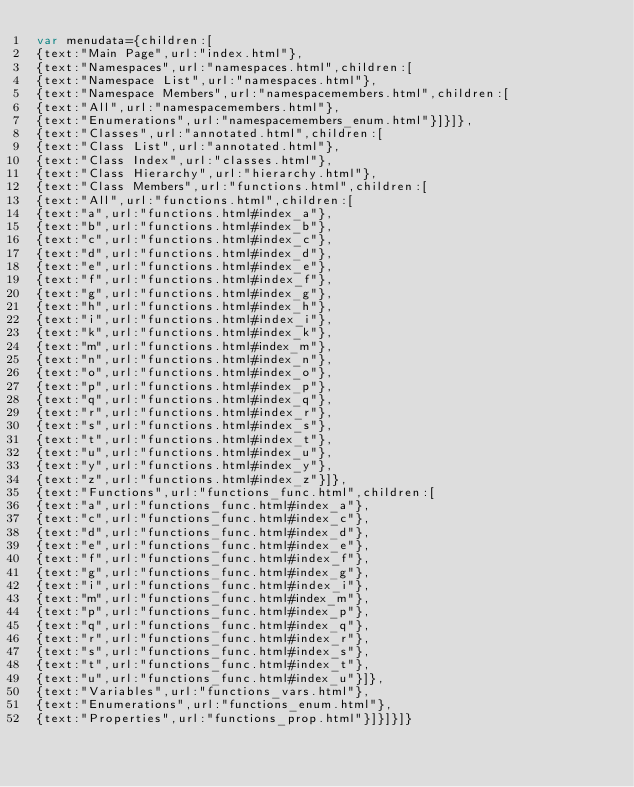<code> <loc_0><loc_0><loc_500><loc_500><_JavaScript_>var menudata={children:[
{text:"Main Page",url:"index.html"},
{text:"Namespaces",url:"namespaces.html",children:[
{text:"Namespace List",url:"namespaces.html"},
{text:"Namespace Members",url:"namespacemembers.html",children:[
{text:"All",url:"namespacemembers.html"},
{text:"Enumerations",url:"namespacemembers_enum.html"}]}]},
{text:"Classes",url:"annotated.html",children:[
{text:"Class List",url:"annotated.html"},
{text:"Class Index",url:"classes.html"},
{text:"Class Hierarchy",url:"hierarchy.html"},
{text:"Class Members",url:"functions.html",children:[
{text:"All",url:"functions.html",children:[
{text:"a",url:"functions.html#index_a"},
{text:"b",url:"functions.html#index_b"},
{text:"c",url:"functions.html#index_c"},
{text:"d",url:"functions.html#index_d"},
{text:"e",url:"functions.html#index_e"},
{text:"f",url:"functions.html#index_f"},
{text:"g",url:"functions.html#index_g"},
{text:"h",url:"functions.html#index_h"},
{text:"i",url:"functions.html#index_i"},
{text:"k",url:"functions.html#index_k"},
{text:"m",url:"functions.html#index_m"},
{text:"n",url:"functions.html#index_n"},
{text:"o",url:"functions.html#index_o"},
{text:"p",url:"functions.html#index_p"},
{text:"q",url:"functions.html#index_q"},
{text:"r",url:"functions.html#index_r"},
{text:"s",url:"functions.html#index_s"},
{text:"t",url:"functions.html#index_t"},
{text:"u",url:"functions.html#index_u"},
{text:"y",url:"functions.html#index_y"},
{text:"z",url:"functions.html#index_z"}]},
{text:"Functions",url:"functions_func.html",children:[
{text:"a",url:"functions_func.html#index_a"},
{text:"c",url:"functions_func.html#index_c"},
{text:"d",url:"functions_func.html#index_d"},
{text:"e",url:"functions_func.html#index_e"},
{text:"f",url:"functions_func.html#index_f"},
{text:"g",url:"functions_func.html#index_g"},
{text:"i",url:"functions_func.html#index_i"},
{text:"m",url:"functions_func.html#index_m"},
{text:"p",url:"functions_func.html#index_p"},
{text:"q",url:"functions_func.html#index_q"},
{text:"r",url:"functions_func.html#index_r"},
{text:"s",url:"functions_func.html#index_s"},
{text:"t",url:"functions_func.html#index_t"},
{text:"u",url:"functions_func.html#index_u"}]},
{text:"Variables",url:"functions_vars.html"},
{text:"Enumerations",url:"functions_enum.html"},
{text:"Properties",url:"functions_prop.html"}]}]}]}
</code> 